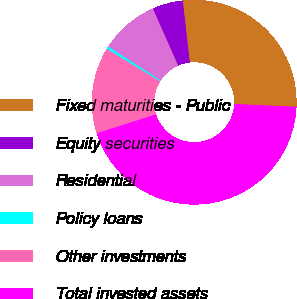Convert chart to OTSL. <chart><loc_0><loc_0><loc_500><loc_500><pie_chart><fcel>Fixed maturities - Public<fcel>Equity securities<fcel>Residential<fcel>Policy loans<fcel>Other investments<fcel>Total invested assets<nl><fcel>27.51%<fcel>4.84%<fcel>9.23%<fcel>0.44%<fcel>13.62%<fcel>44.37%<nl></chart> 